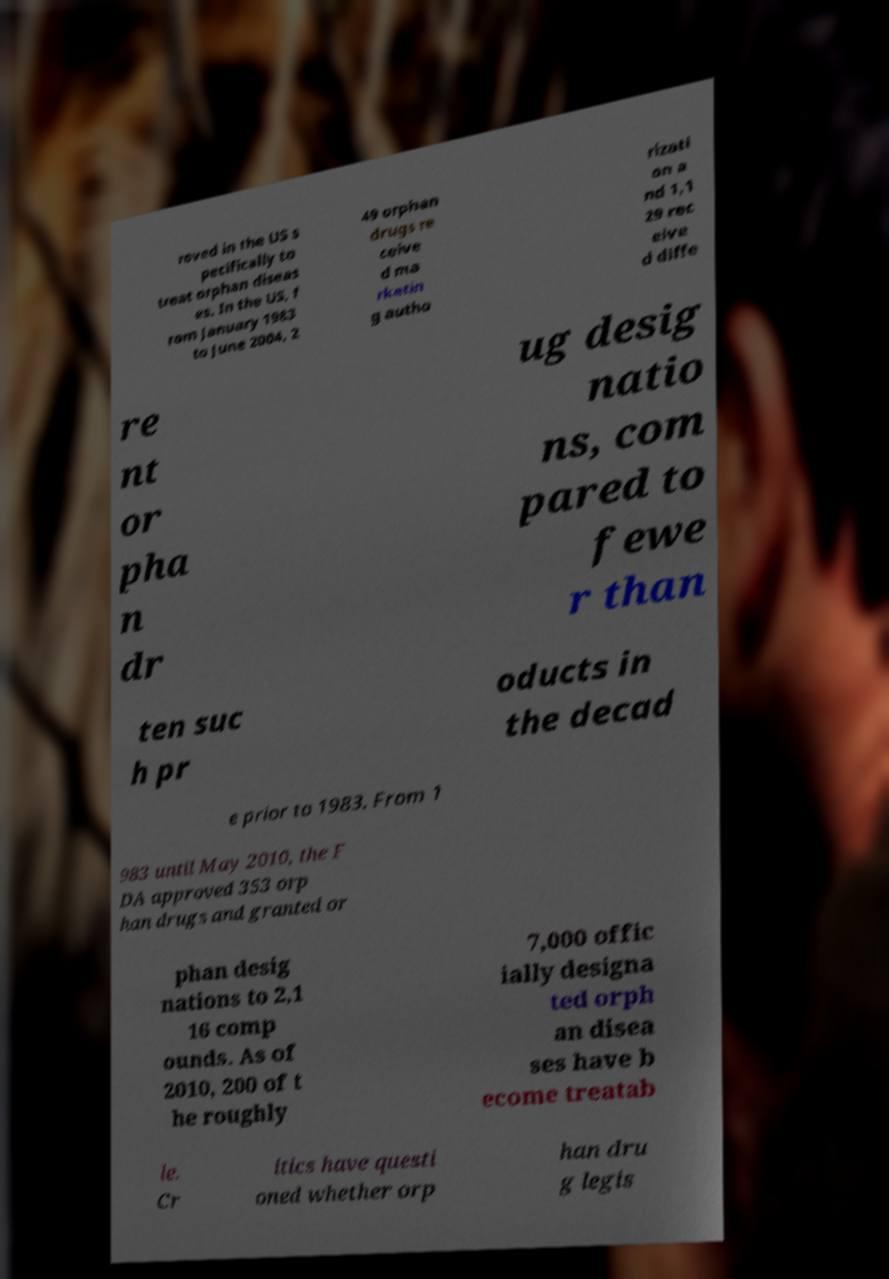For documentation purposes, I need the text within this image transcribed. Could you provide that? roved in the US s pecifically to treat orphan diseas es. In the US, f rom January 1983 to June 2004, 2 49 orphan drugs re ceive d ma rketin g autho rizati on a nd 1,1 29 rec eive d diffe re nt or pha n dr ug desig natio ns, com pared to fewe r than ten suc h pr oducts in the decad e prior to 1983. From 1 983 until May 2010, the F DA approved 353 orp han drugs and granted or phan desig nations to 2,1 16 comp ounds. As of 2010, 200 of t he roughly 7,000 offic ially designa ted orph an disea ses have b ecome treatab le. Cr itics have questi oned whether orp han dru g legis 